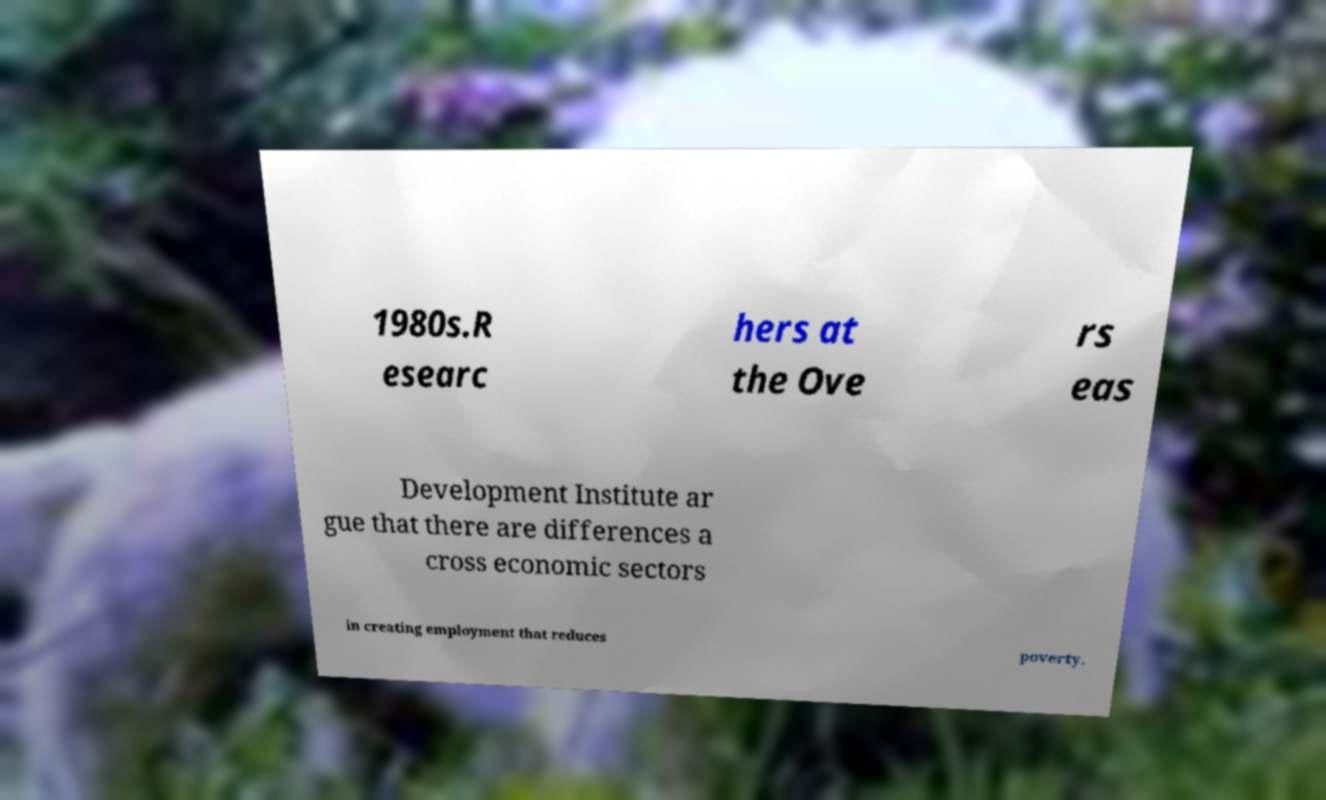Could you assist in decoding the text presented in this image and type it out clearly? 1980s.R esearc hers at the Ove rs eas Development Institute ar gue that there are differences a cross economic sectors in creating employment that reduces poverty. 